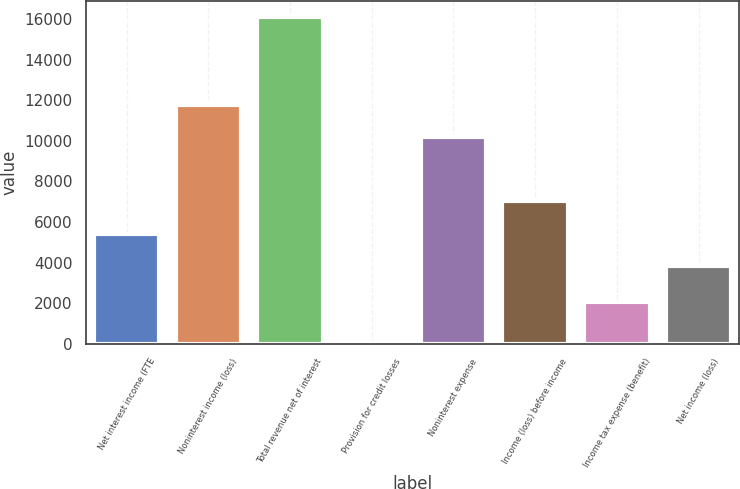Convert chart. <chart><loc_0><loc_0><loc_500><loc_500><bar_chart><fcel>Net interest income (FTE<fcel>Noninterest income (loss)<fcel>Total revenue net of interest<fcel>Provision for credit losses<fcel>Noninterest expense<fcel>Income (loss) before income<fcel>Income tax expense (benefit)<fcel>Net income (loss)<nl><fcel>5423.9<fcel>11774.9<fcel>16090<fcel>31<fcel>10169<fcel>7029.8<fcel>2072<fcel>3818<nl></chart> 